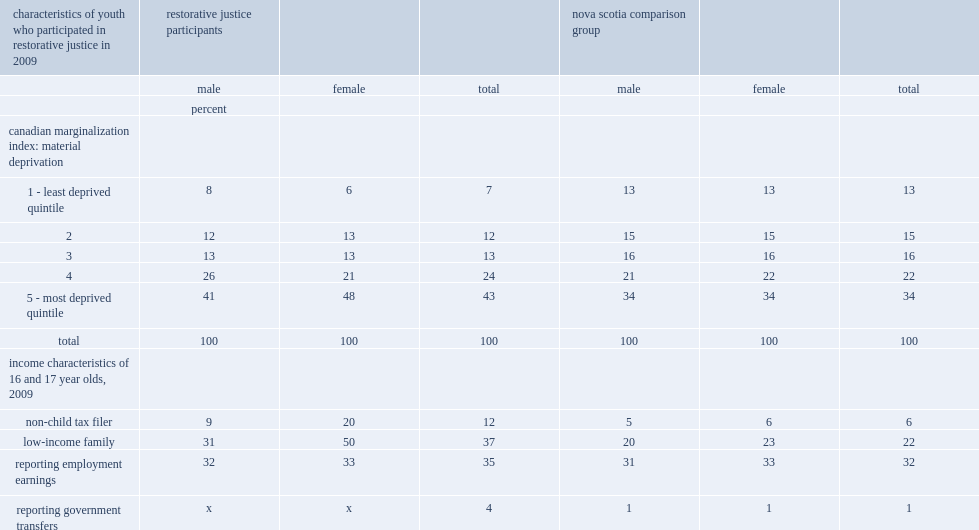What is the percentage of youth who participated in restorative justice lived in a location that was in the bottom quintile in 2009/2010? 0.43. What is the percentage of all nova scotia youth participated in restorative justice? 34.0. For those lived in a location that was in the bottom quintile,who has a higher percentage of rj participants? Female. What is the percentage of girls who participated in restorative justice appeared to be no longer living with their parents? 20.0. What is the percentage of male rj participants filed taxes but were not identified as living with a parent? 9.0. Among all nova scotian 16- and 17-year-old youths, what is the percentage of youths who were identified as non-child filers, not living with parents, with little difference by gender? 6.0. What is the percentage of tax filing girls who were living in a low-income situation? 50.0. What is the percentage of tax filing boys who were living in a low-income situation? 31.0. Among 16- and 17-year-old nova scotians who filed taxes, what is the percentage of them who living in low income? 22.0. Among 16- and 17-year-olds,what is the percentage of rj participants who reported employment income in 2009? 35.0. Among 16- and 17-year-olds,what is the percentage of nova scotia youth who reported employment income in 2009? 32.0. 